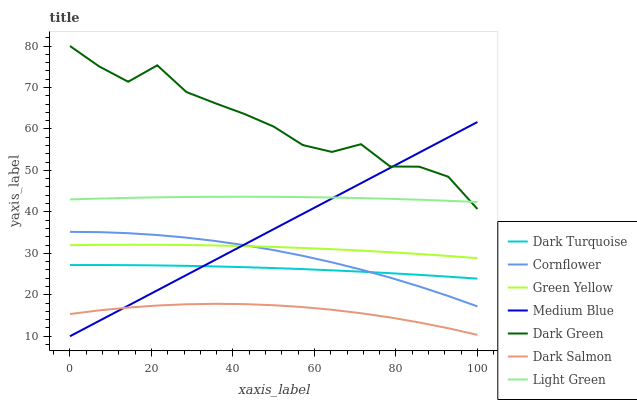Does Dark Salmon have the minimum area under the curve?
Answer yes or no. Yes. Does Dark Green have the maximum area under the curve?
Answer yes or no. Yes. Does Dark Turquoise have the minimum area under the curve?
Answer yes or no. No. Does Dark Turquoise have the maximum area under the curve?
Answer yes or no. No. Is Medium Blue the smoothest?
Answer yes or no. Yes. Is Dark Green the roughest?
Answer yes or no. Yes. Is Dark Turquoise the smoothest?
Answer yes or no. No. Is Dark Turquoise the roughest?
Answer yes or no. No. Does Medium Blue have the lowest value?
Answer yes or no. Yes. Does Dark Turquoise have the lowest value?
Answer yes or no. No. Does Dark Green have the highest value?
Answer yes or no. Yes. Does Dark Turquoise have the highest value?
Answer yes or no. No. Is Cornflower less than Light Green?
Answer yes or no. Yes. Is Green Yellow greater than Dark Turquoise?
Answer yes or no. Yes. Does Medium Blue intersect Dark Turquoise?
Answer yes or no. Yes. Is Medium Blue less than Dark Turquoise?
Answer yes or no. No. Is Medium Blue greater than Dark Turquoise?
Answer yes or no. No. Does Cornflower intersect Light Green?
Answer yes or no. No. 